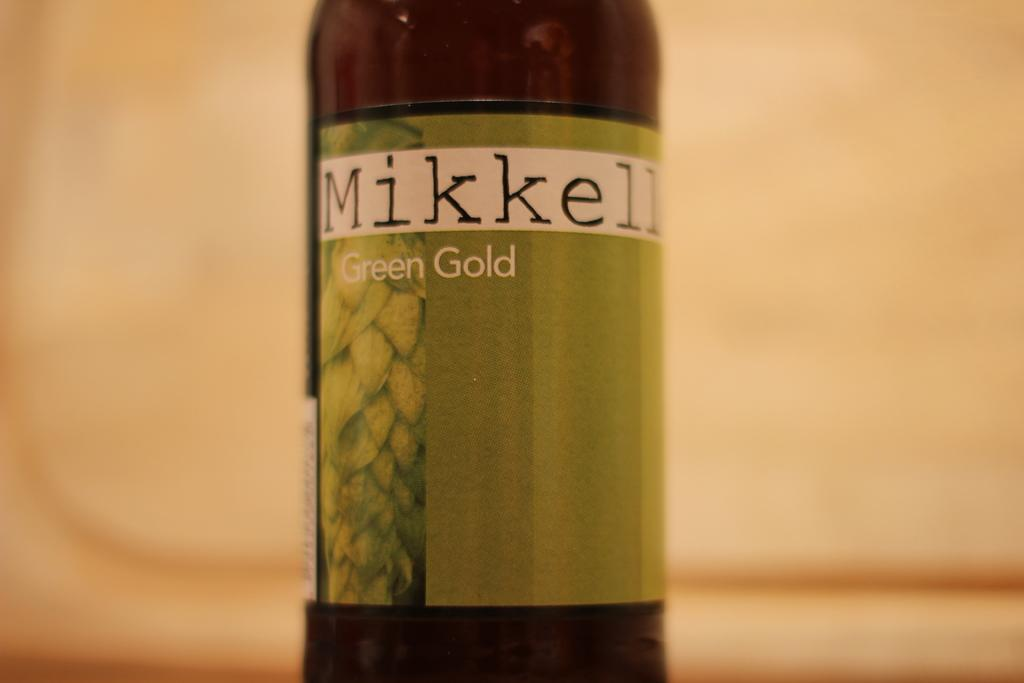<image>
Relay a brief, clear account of the picture shown. A shot of the label portion of a Mikkeller Green Gold beer bottle. 